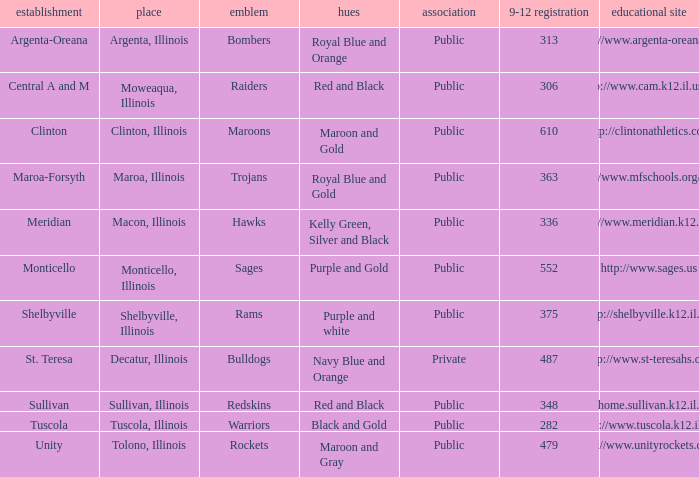What's the name of the city or town of the school that operates the http://www.mfschools.org/high/ website? Maroa-Forsyth. 